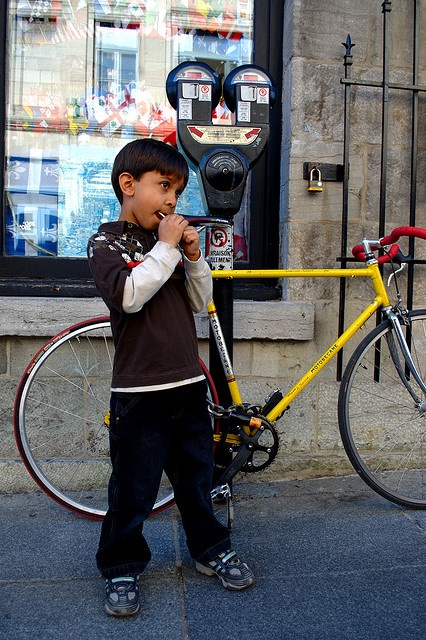Describe the objects in this image and their specific colors. I can see bicycle in black, gray, and darkgray tones, people in black, lightgray, gray, and darkgray tones, and parking meter in black, lightgray, gray, and navy tones in this image. 